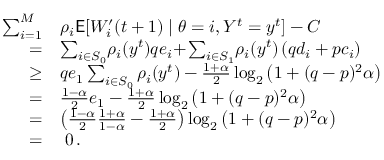Convert formula to latex. <formula><loc_0><loc_0><loc_500><loc_500>\begin{array} { r l } { \sum _ { i = 1 } ^ { M } } & { \rho _ { i } E [ W _ { i } ^ { \prime } ( t + 1 ) | \theta = i , Y ^ { t } = y ^ { t } ] - C } \\ { = } & { \sum _ { i \in S _ { 0 } } \, \rho _ { i } ( y ^ { t } ) q e _ { i } \, + \, \sum _ { i \in S _ { 1 } } \, \rho _ { i } ( y ^ { t } ) \left ( q d _ { i } + p c _ { i } \right ) } \\ { \geq } & { q e _ { 1 } \sum _ { i \in S _ { 0 } } \rho _ { i } ( y ^ { t } ) - \frac { 1 + \alpha } { 2 } \log _ { 2 } \left ( 1 + ( q - p ) ^ { 2 } \alpha \right ) } \\ { = } & { \frac { 1 - \alpha } { 2 } e _ { 1 } - \frac { 1 + \alpha } { 2 } \log _ { 2 } \left ( 1 + ( q - p ) ^ { 2 } \alpha \right ) } \\ { = } & { \left ( \frac { 1 - \alpha } { 2 } \frac { 1 + \alpha } { 1 - \alpha } - \frac { 1 + \alpha } { 2 } \right ) \log _ { 2 } \left ( 1 + ( q - p ) ^ { 2 } \alpha \right ) } \\ { = } & { \, 0 \, . } \end{array}</formula> 